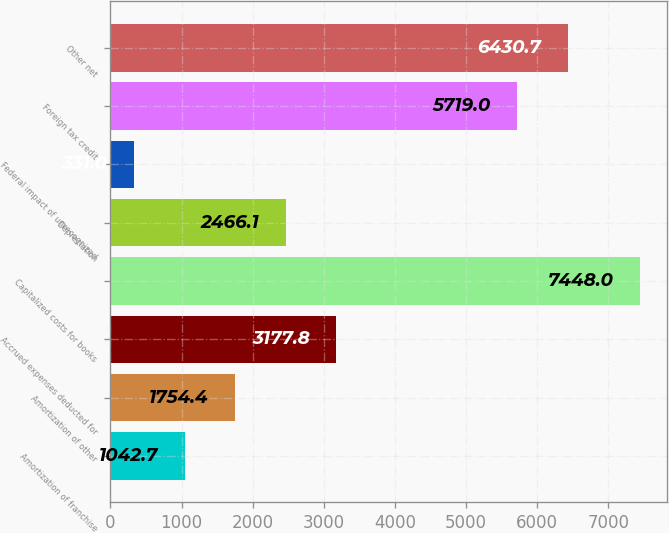<chart> <loc_0><loc_0><loc_500><loc_500><bar_chart><fcel>Amortization of franchise<fcel>Amortization of other<fcel>Accrued expenses deducted for<fcel>Capitalized costs for books<fcel>Depreciation<fcel>Federal impact of unrecognized<fcel>Foreign tax credit<fcel>Other net<nl><fcel>1042.7<fcel>1754.4<fcel>3177.8<fcel>7448<fcel>2466.1<fcel>331<fcel>5719<fcel>6430.7<nl></chart> 